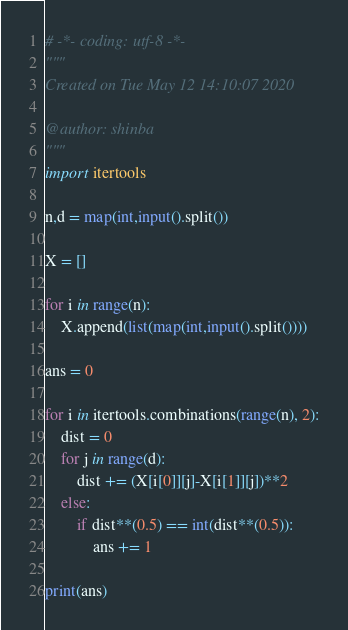<code> <loc_0><loc_0><loc_500><loc_500><_Python_># -*- coding: utf-8 -*-
"""
Created on Tue May 12 14:10:07 2020

@author: shinba
"""
import itertools

n,d = map(int,input().split())

X = []

for i in range(n):
    X.append(list(map(int,input().split())))

ans = 0

for i in itertools.combinations(range(n), 2):
    dist = 0
    for j in range(d):
        dist += (X[i[0]][j]-X[i[1]][j])**2
    else:
        if dist**(0.5) == int(dist**(0.5)):
            ans += 1

print(ans)
</code> 